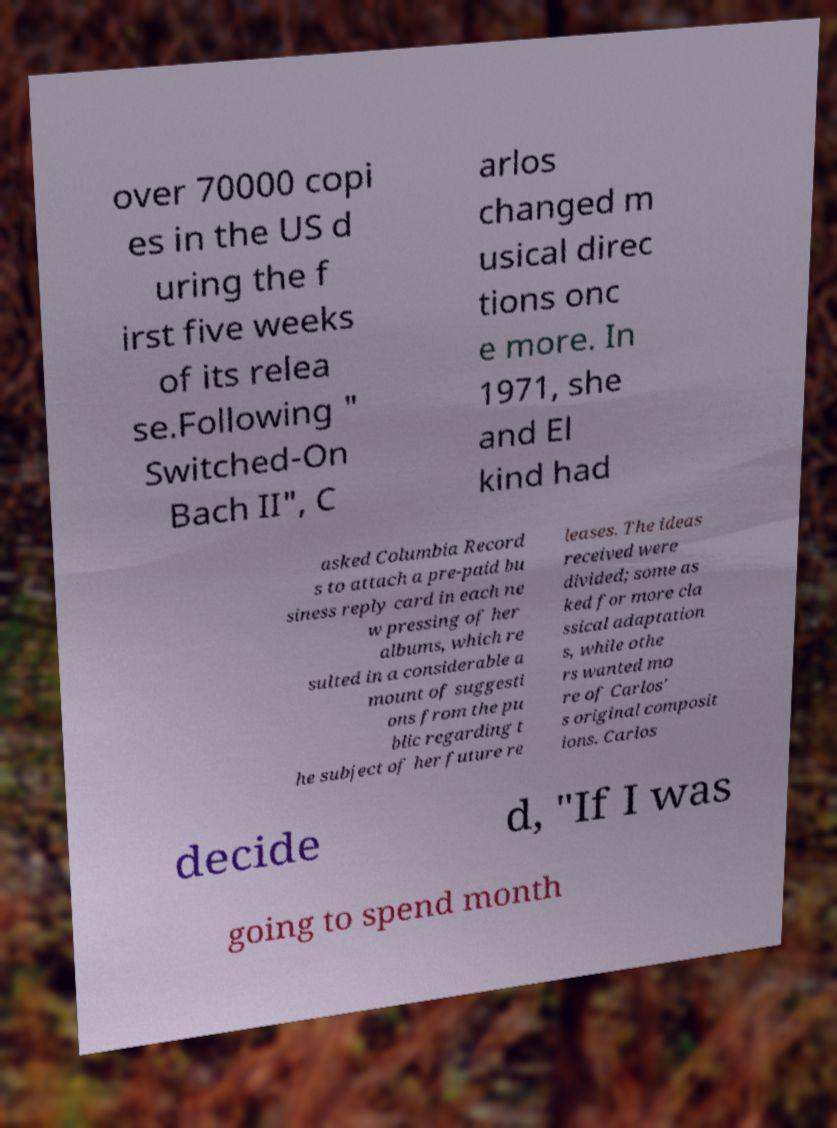For documentation purposes, I need the text within this image transcribed. Could you provide that? over 70000 copi es in the US d uring the f irst five weeks of its relea se.Following " Switched-On Bach II", C arlos changed m usical direc tions onc e more. In 1971, she and El kind had asked Columbia Record s to attach a pre-paid bu siness reply card in each ne w pressing of her albums, which re sulted in a considerable a mount of suggesti ons from the pu blic regarding t he subject of her future re leases. The ideas received were divided; some as ked for more cla ssical adaptation s, while othe rs wanted mo re of Carlos' s original composit ions. Carlos decide d, "If I was going to spend month 